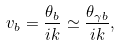<formula> <loc_0><loc_0><loc_500><loc_500>v _ { b } = \frac { \theta _ { b } } { i k } \simeq \frac { \theta _ { \gamma b } } { i k } ,</formula> 